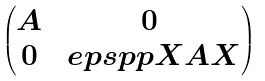<formula> <loc_0><loc_0><loc_500><loc_500>\begin{pmatrix} A & 0 \\ 0 & \ e p s p p X A X \end{pmatrix}</formula> 